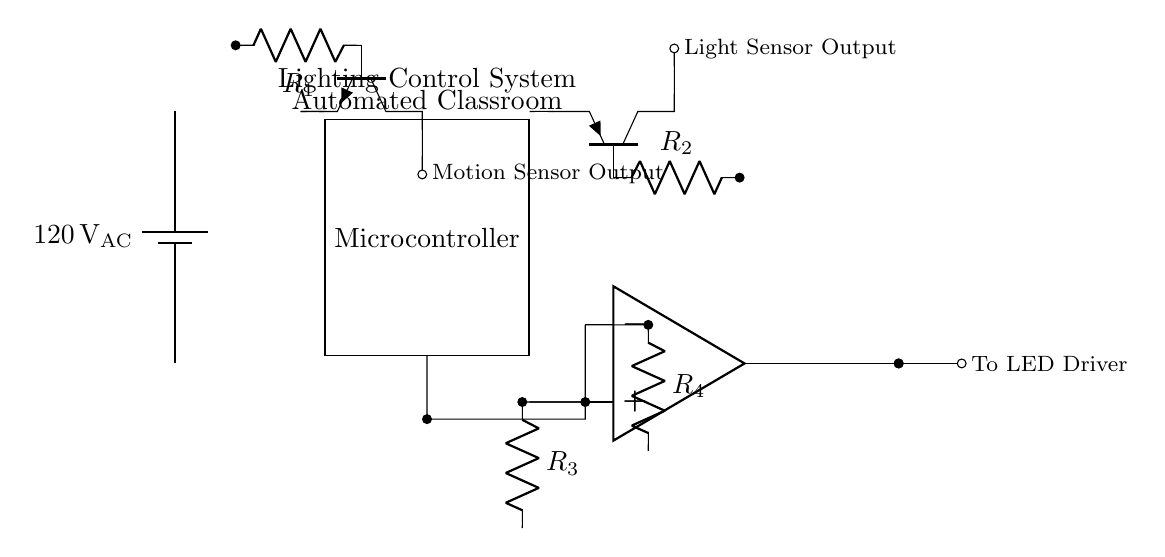What is the input voltage for the circuit? The battery supplies an alternating current voltage of 120 volts, which can be found at the starting point of the circuit diagram indicated by the battery label.
Answer: 120 volts What type of sensor is used to detect motion? The circuit diagram includes an npn transistor labeled as the motion sensor, which means it functions as a motion detection device by utilizing its collector-emitter current to signal motion detection.
Answer: NPN How many resistors are present in the circuit? There are four resistors identified by the labels R1, R2, R3, and R4 connected throughout the circuit, as shown by the resistor symbols adjacent to the connections in the diagram.
Answer: Four What is the output of the motion sensor? The output from the motion sensor is indicated by a labeled connection that describes it as "Motion Sensor Output," showing where the sensor's signal is sent in the circuit.
Answer: Motion Sensor Output Which component processes both motion and light sensor inputs? The microcontroller is the component that receives inputs from both the motion sensor and light sensor, as represented by the connections from those sensors to the MCU in the diagram.
Answer: Microcontroller What type of control circuit is utilized for dimming? An operational amplifier denotes a dimming circuit, which adjusts the brightness of the connected output based on the input signals, indicated by the op amp symbol in the diagram.
Answer: Operational Amplifier What is the purpose of R4 in the circuit? R4 is connected to the operational amplifier and helps set a reference voltage for the circuit based on the light levels, allowing it to regulate brightness effectively; this can be inferred from its connection in the feedback loop.
Answer: Reference Voltage Resistor 